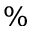Convert formula to latex. <formula><loc_0><loc_0><loc_500><loc_500>\%</formula> 